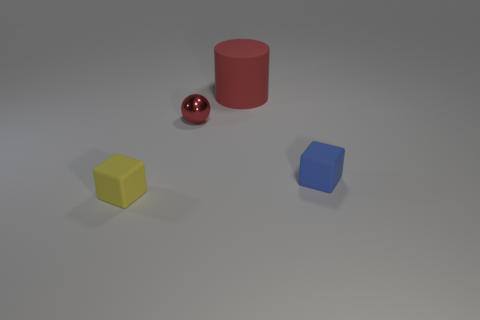What number of red metallic balls are there? 1 